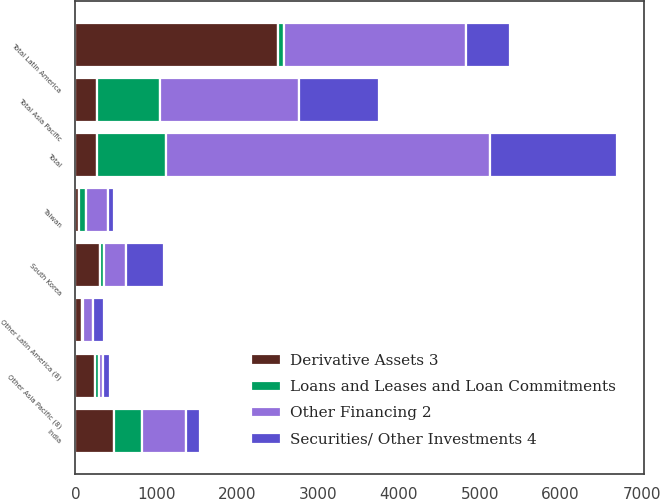Convert chart. <chart><loc_0><loc_0><loc_500><loc_500><stacked_bar_chart><ecel><fcel>India<fcel>South Korea<fcel>Taiwan<fcel>Other Asia Pacific (8)<fcel>Total Asia Pacific<fcel>Other Latin America (8)<fcel>Total Latin America<fcel>Total<nl><fcel>Other Financing 2<fcel>547<fcel>267<fcel>266<fcel>46<fcel>1723<fcel>126<fcel>2259<fcel>4008<nl><fcel>Securities/ Other Investments 4<fcel>176<fcel>474<fcel>77<fcel>88<fcel>989<fcel>134<fcel>540<fcel>1571<nl><fcel>Loans and Leases and Loan Commitments<fcel>341<fcel>52<fcel>84<fcel>43<fcel>774<fcel>7<fcel>65<fcel>848<nl><fcel>Derivative Assets 3<fcel>482<fcel>305<fcel>48<fcel>248<fcel>266.5<fcel>84<fcel>2509<fcel>266.5<nl></chart> 